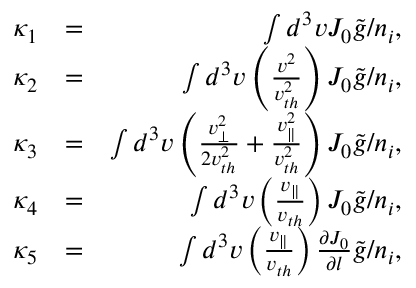Convert formula to latex. <formula><loc_0><loc_0><loc_500><loc_500>\begin{array} { r l r } { \kappa _ { 1 } } & { = } & { \int d ^ { 3 } v J _ { 0 } \tilde { g } / n _ { i } , } \\ { \kappa _ { 2 } } & { = } & { \int d ^ { 3 } v \left ( \frac { v ^ { 2 } } { v _ { t h } ^ { 2 } } \right ) J _ { 0 } \tilde { g } / n _ { i } , } \\ { \kappa _ { 3 } } & { = } & { \int d ^ { 3 } v \left ( \frac { v _ { \perp } ^ { 2 } } { 2 v _ { t h } ^ { 2 } } + \frac { v _ { \| } ^ { 2 } } { v _ { t h } ^ { 2 } } \right ) J _ { 0 } \tilde { g } / n _ { i } , } \\ { \kappa _ { 4 } } & { = } & { \int d ^ { 3 } v \left ( \frac { v _ { \| } } { v _ { t h } } \right ) J _ { 0 } \tilde { g } / n _ { i } , } \\ { \kappa _ { 5 } } & { = } & { \int d ^ { 3 } v \left ( \frac { v _ { \| } } { v _ { t h } } \right ) \frac { \partial J _ { 0 } } { \partial l } \tilde { g } / n _ { i } , } \end{array}</formula> 